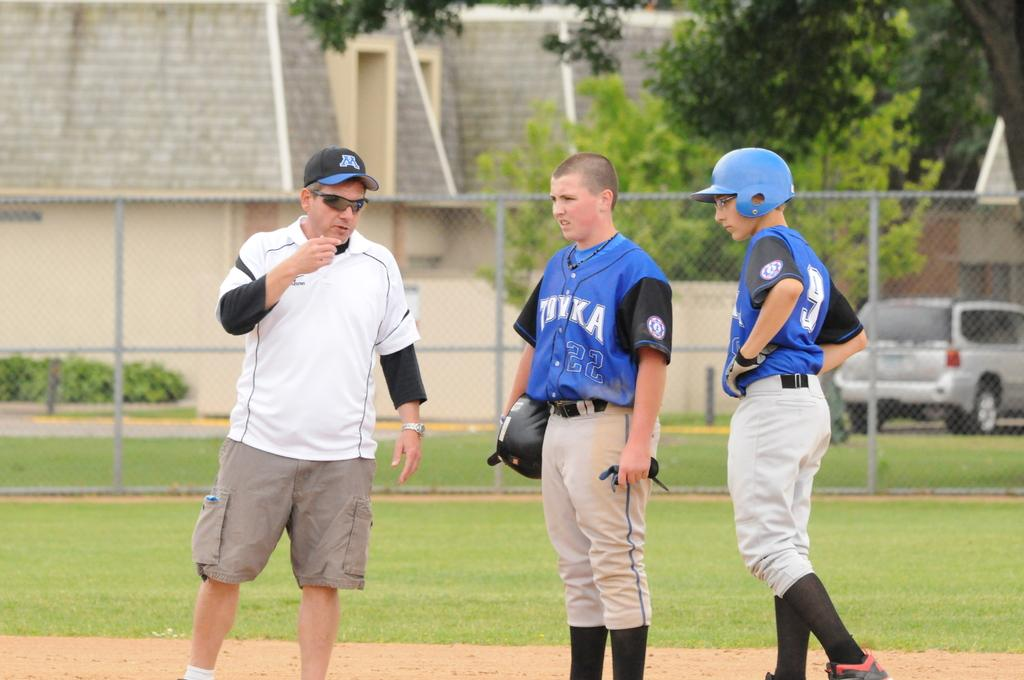<image>
Describe the image concisely. Two baseball players on the Tonka team wearing blue jerseys stand on the field listening to their coach talk. 